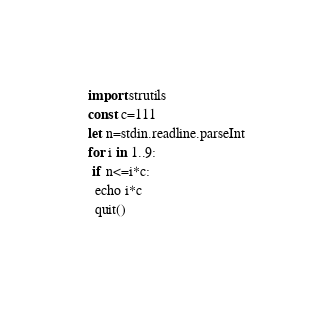<code> <loc_0><loc_0><loc_500><loc_500><_Nim_>import strutils
const c=111
let n=stdin.readline.parseInt
for i in 1..9:
 if n<=i*c:
  echo i*c
  quit()</code> 